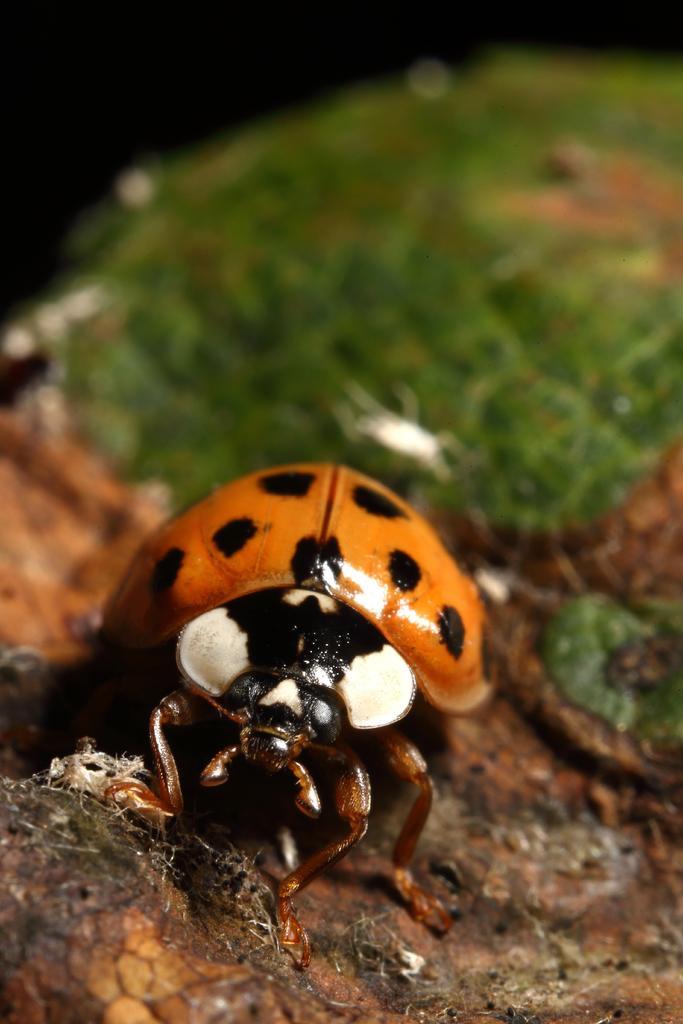In one or two sentences, can you explain what this image depicts? In the front of the image I can see a ladybug is on the surface. In the background of the image it is blurry.  